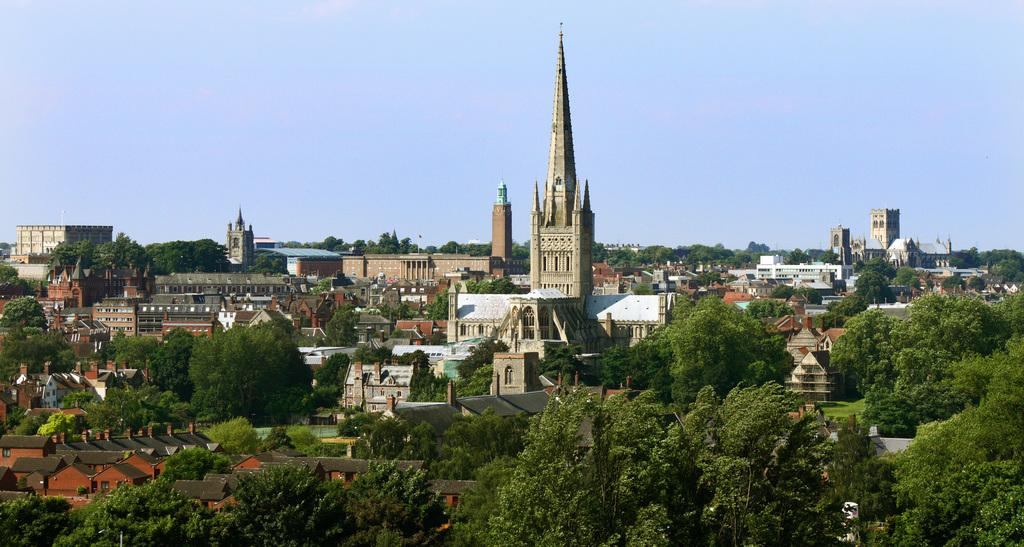What types of structures are present in the image? There are buildings in the image. What other natural elements can be seen in the image? There are trees in the image. What part of the natural environment is visible in the image? The sky is visible in the background of the image. What type of veil can be seen covering the trees in the image? There is no veil present in the image; the trees are not covered. 